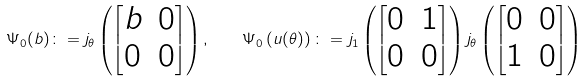<formula> <loc_0><loc_0><loc_500><loc_500>\Psi _ { 0 } ( b ) \colon = j _ { \theta } \left ( \begin{bmatrix} b & 0 \\ 0 & 0 \end{bmatrix} \right ) , \quad \Psi _ { 0 } \left ( u ( \theta ) \right ) \colon = j _ { 1 } \left ( \begin{bmatrix} 0 & 1 \\ 0 & 0 \end{bmatrix} \right ) j _ { \theta } \left ( \begin{bmatrix} 0 & 0 \\ 1 & 0 \end{bmatrix} \right )</formula> 